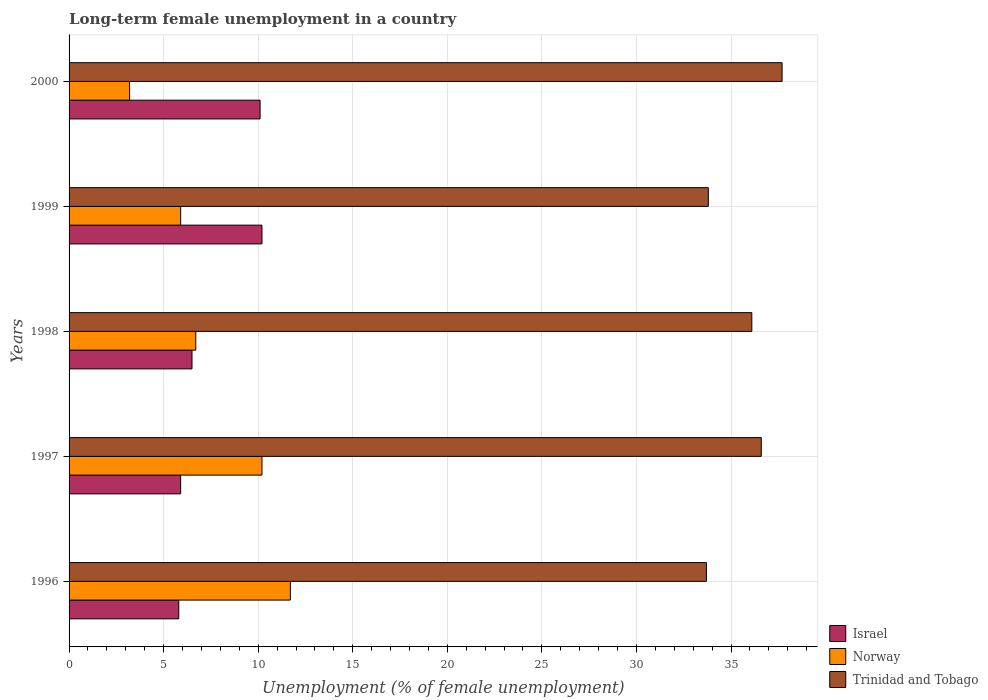How many different coloured bars are there?
Your answer should be very brief. 3. How many groups of bars are there?
Your answer should be very brief. 5. Are the number of bars per tick equal to the number of legend labels?
Provide a short and direct response. Yes. Are the number of bars on each tick of the Y-axis equal?
Ensure brevity in your answer.  Yes. How many bars are there on the 4th tick from the top?
Offer a very short reply. 3. How many bars are there on the 2nd tick from the bottom?
Ensure brevity in your answer.  3. What is the label of the 3rd group of bars from the top?
Your answer should be compact. 1998. What is the percentage of long-term unemployed female population in Trinidad and Tobago in 1997?
Keep it short and to the point. 36.6. Across all years, what is the maximum percentage of long-term unemployed female population in Norway?
Make the answer very short. 11.7. Across all years, what is the minimum percentage of long-term unemployed female population in Trinidad and Tobago?
Keep it short and to the point. 33.7. What is the total percentage of long-term unemployed female population in Norway in the graph?
Provide a succinct answer. 37.7. What is the difference between the percentage of long-term unemployed female population in Israel in 1996 and that in 1998?
Provide a short and direct response. -0.7. What is the difference between the percentage of long-term unemployed female population in Norway in 2000 and the percentage of long-term unemployed female population in Israel in 1998?
Offer a very short reply. -3.3. What is the average percentage of long-term unemployed female population in Norway per year?
Provide a succinct answer. 7.54. In the year 1998, what is the difference between the percentage of long-term unemployed female population in Trinidad and Tobago and percentage of long-term unemployed female population in Israel?
Ensure brevity in your answer.  29.6. In how many years, is the percentage of long-term unemployed female population in Trinidad and Tobago greater than 19 %?
Give a very brief answer. 5. What is the ratio of the percentage of long-term unemployed female population in Norway in 1996 to that in 2000?
Your response must be concise. 3.66. Is the difference between the percentage of long-term unemployed female population in Trinidad and Tobago in 1996 and 2000 greater than the difference between the percentage of long-term unemployed female population in Israel in 1996 and 2000?
Offer a very short reply. Yes. What is the difference between the highest and the second highest percentage of long-term unemployed female population in Trinidad and Tobago?
Your answer should be compact. 1.1. What is the difference between the highest and the lowest percentage of long-term unemployed female population in Israel?
Offer a very short reply. 4.4. In how many years, is the percentage of long-term unemployed female population in Norway greater than the average percentage of long-term unemployed female population in Norway taken over all years?
Make the answer very short. 2. Is it the case that in every year, the sum of the percentage of long-term unemployed female population in Trinidad and Tobago and percentage of long-term unemployed female population in Norway is greater than the percentage of long-term unemployed female population in Israel?
Keep it short and to the point. Yes. How many bars are there?
Your response must be concise. 15. Are all the bars in the graph horizontal?
Offer a terse response. Yes. How many years are there in the graph?
Your answer should be compact. 5. What is the difference between two consecutive major ticks on the X-axis?
Your response must be concise. 5. Are the values on the major ticks of X-axis written in scientific E-notation?
Your answer should be very brief. No. Does the graph contain any zero values?
Ensure brevity in your answer.  No. Does the graph contain grids?
Offer a very short reply. Yes. Where does the legend appear in the graph?
Offer a terse response. Bottom right. How are the legend labels stacked?
Keep it short and to the point. Vertical. What is the title of the graph?
Your response must be concise. Long-term female unemployment in a country. Does "Benin" appear as one of the legend labels in the graph?
Ensure brevity in your answer.  No. What is the label or title of the X-axis?
Ensure brevity in your answer.  Unemployment (% of female unemployment). What is the label or title of the Y-axis?
Ensure brevity in your answer.  Years. What is the Unemployment (% of female unemployment) in Israel in 1996?
Give a very brief answer. 5.8. What is the Unemployment (% of female unemployment) of Norway in 1996?
Make the answer very short. 11.7. What is the Unemployment (% of female unemployment) in Trinidad and Tobago in 1996?
Offer a terse response. 33.7. What is the Unemployment (% of female unemployment) in Israel in 1997?
Your response must be concise. 5.9. What is the Unemployment (% of female unemployment) in Norway in 1997?
Keep it short and to the point. 10.2. What is the Unemployment (% of female unemployment) in Trinidad and Tobago in 1997?
Keep it short and to the point. 36.6. What is the Unemployment (% of female unemployment) of Israel in 1998?
Offer a very short reply. 6.5. What is the Unemployment (% of female unemployment) in Norway in 1998?
Provide a succinct answer. 6.7. What is the Unemployment (% of female unemployment) of Trinidad and Tobago in 1998?
Make the answer very short. 36.1. What is the Unemployment (% of female unemployment) in Israel in 1999?
Provide a short and direct response. 10.2. What is the Unemployment (% of female unemployment) in Norway in 1999?
Offer a very short reply. 5.9. What is the Unemployment (% of female unemployment) in Trinidad and Tobago in 1999?
Ensure brevity in your answer.  33.8. What is the Unemployment (% of female unemployment) in Israel in 2000?
Offer a terse response. 10.1. What is the Unemployment (% of female unemployment) in Norway in 2000?
Provide a succinct answer. 3.2. What is the Unemployment (% of female unemployment) in Trinidad and Tobago in 2000?
Offer a terse response. 37.7. Across all years, what is the maximum Unemployment (% of female unemployment) in Israel?
Make the answer very short. 10.2. Across all years, what is the maximum Unemployment (% of female unemployment) of Norway?
Your response must be concise. 11.7. Across all years, what is the maximum Unemployment (% of female unemployment) in Trinidad and Tobago?
Your answer should be compact. 37.7. Across all years, what is the minimum Unemployment (% of female unemployment) in Israel?
Give a very brief answer. 5.8. Across all years, what is the minimum Unemployment (% of female unemployment) of Norway?
Give a very brief answer. 3.2. Across all years, what is the minimum Unemployment (% of female unemployment) of Trinidad and Tobago?
Provide a short and direct response. 33.7. What is the total Unemployment (% of female unemployment) of Israel in the graph?
Offer a very short reply. 38.5. What is the total Unemployment (% of female unemployment) in Norway in the graph?
Your response must be concise. 37.7. What is the total Unemployment (% of female unemployment) in Trinidad and Tobago in the graph?
Your answer should be compact. 177.9. What is the difference between the Unemployment (% of female unemployment) of Israel in 1996 and that in 1998?
Ensure brevity in your answer.  -0.7. What is the difference between the Unemployment (% of female unemployment) in Norway in 1996 and that in 1998?
Keep it short and to the point. 5. What is the difference between the Unemployment (% of female unemployment) of Norway in 1996 and that in 1999?
Offer a very short reply. 5.8. What is the difference between the Unemployment (% of female unemployment) of Trinidad and Tobago in 1996 and that in 1999?
Offer a very short reply. -0.1. What is the difference between the Unemployment (% of female unemployment) of Israel in 1996 and that in 2000?
Offer a terse response. -4.3. What is the difference between the Unemployment (% of female unemployment) of Norway in 1996 and that in 2000?
Your response must be concise. 8.5. What is the difference between the Unemployment (% of female unemployment) of Trinidad and Tobago in 1997 and that in 1998?
Your answer should be compact. 0.5. What is the difference between the Unemployment (% of female unemployment) of Israel in 1997 and that in 1999?
Provide a short and direct response. -4.3. What is the difference between the Unemployment (% of female unemployment) of Norway in 1997 and that in 1999?
Offer a terse response. 4.3. What is the difference between the Unemployment (% of female unemployment) in Trinidad and Tobago in 1997 and that in 1999?
Your response must be concise. 2.8. What is the difference between the Unemployment (% of female unemployment) of Trinidad and Tobago in 1997 and that in 2000?
Provide a short and direct response. -1.1. What is the difference between the Unemployment (% of female unemployment) in Norway in 1998 and that in 1999?
Keep it short and to the point. 0.8. What is the difference between the Unemployment (% of female unemployment) in Israel in 1998 and that in 2000?
Your answer should be very brief. -3.6. What is the difference between the Unemployment (% of female unemployment) in Norway in 1998 and that in 2000?
Your answer should be compact. 3.5. What is the difference between the Unemployment (% of female unemployment) in Trinidad and Tobago in 1998 and that in 2000?
Ensure brevity in your answer.  -1.6. What is the difference between the Unemployment (% of female unemployment) in Norway in 1999 and that in 2000?
Ensure brevity in your answer.  2.7. What is the difference between the Unemployment (% of female unemployment) of Israel in 1996 and the Unemployment (% of female unemployment) of Trinidad and Tobago in 1997?
Offer a terse response. -30.8. What is the difference between the Unemployment (% of female unemployment) of Norway in 1996 and the Unemployment (% of female unemployment) of Trinidad and Tobago in 1997?
Offer a very short reply. -24.9. What is the difference between the Unemployment (% of female unemployment) in Israel in 1996 and the Unemployment (% of female unemployment) in Norway in 1998?
Keep it short and to the point. -0.9. What is the difference between the Unemployment (% of female unemployment) of Israel in 1996 and the Unemployment (% of female unemployment) of Trinidad and Tobago in 1998?
Give a very brief answer. -30.3. What is the difference between the Unemployment (% of female unemployment) in Norway in 1996 and the Unemployment (% of female unemployment) in Trinidad and Tobago in 1998?
Provide a short and direct response. -24.4. What is the difference between the Unemployment (% of female unemployment) of Norway in 1996 and the Unemployment (% of female unemployment) of Trinidad and Tobago in 1999?
Make the answer very short. -22.1. What is the difference between the Unemployment (% of female unemployment) of Israel in 1996 and the Unemployment (% of female unemployment) of Norway in 2000?
Make the answer very short. 2.6. What is the difference between the Unemployment (% of female unemployment) of Israel in 1996 and the Unemployment (% of female unemployment) of Trinidad and Tobago in 2000?
Your answer should be compact. -31.9. What is the difference between the Unemployment (% of female unemployment) of Israel in 1997 and the Unemployment (% of female unemployment) of Trinidad and Tobago in 1998?
Keep it short and to the point. -30.2. What is the difference between the Unemployment (% of female unemployment) of Norway in 1997 and the Unemployment (% of female unemployment) of Trinidad and Tobago in 1998?
Make the answer very short. -25.9. What is the difference between the Unemployment (% of female unemployment) of Israel in 1997 and the Unemployment (% of female unemployment) of Norway in 1999?
Your answer should be compact. 0. What is the difference between the Unemployment (% of female unemployment) in Israel in 1997 and the Unemployment (% of female unemployment) in Trinidad and Tobago in 1999?
Offer a terse response. -27.9. What is the difference between the Unemployment (% of female unemployment) of Norway in 1997 and the Unemployment (% of female unemployment) of Trinidad and Tobago in 1999?
Your answer should be compact. -23.6. What is the difference between the Unemployment (% of female unemployment) in Israel in 1997 and the Unemployment (% of female unemployment) in Norway in 2000?
Make the answer very short. 2.7. What is the difference between the Unemployment (% of female unemployment) in Israel in 1997 and the Unemployment (% of female unemployment) in Trinidad and Tobago in 2000?
Provide a succinct answer. -31.8. What is the difference between the Unemployment (% of female unemployment) in Norway in 1997 and the Unemployment (% of female unemployment) in Trinidad and Tobago in 2000?
Provide a short and direct response. -27.5. What is the difference between the Unemployment (% of female unemployment) in Israel in 1998 and the Unemployment (% of female unemployment) in Norway in 1999?
Provide a succinct answer. 0.6. What is the difference between the Unemployment (% of female unemployment) in Israel in 1998 and the Unemployment (% of female unemployment) in Trinidad and Tobago in 1999?
Your response must be concise. -27.3. What is the difference between the Unemployment (% of female unemployment) in Norway in 1998 and the Unemployment (% of female unemployment) in Trinidad and Tobago in 1999?
Ensure brevity in your answer.  -27.1. What is the difference between the Unemployment (% of female unemployment) in Israel in 1998 and the Unemployment (% of female unemployment) in Norway in 2000?
Your answer should be very brief. 3.3. What is the difference between the Unemployment (% of female unemployment) in Israel in 1998 and the Unemployment (% of female unemployment) in Trinidad and Tobago in 2000?
Give a very brief answer. -31.2. What is the difference between the Unemployment (% of female unemployment) of Norway in 1998 and the Unemployment (% of female unemployment) of Trinidad and Tobago in 2000?
Ensure brevity in your answer.  -31. What is the difference between the Unemployment (% of female unemployment) of Israel in 1999 and the Unemployment (% of female unemployment) of Trinidad and Tobago in 2000?
Offer a very short reply. -27.5. What is the difference between the Unemployment (% of female unemployment) in Norway in 1999 and the Unemployment (% of female unemployment) in Trinidad and Tobago in 2000?
Provide a short and direct response. -31.8. What is the average Unemployment (% of female unemployment) in Israel per year?
Give a very brief answer. 7.7. What is the average Unemployment (% of female unemployment) of Norway per year?
Your response must be concise. 7.54. What is the average Unemployment (% of female unemployment) of Trinidad and Tobago per year?
Keep it short and to the point. 35.58. In the year 1996, what is the difference between the Unemployment (% of female unemployment) in Israel and Unemployment (% of female unemployment) in Trinidad and Tobago?
Provide a short and direct response. -27.9. In the year 1997, what is the difference between the Unemployment (% of female unemployment) of Israel and Unemployment (% of female unemployment) of Trinidad and Tobago?
Provide a short and direct response. -30.7. In the year 1997, what is the difference between the Unemployment (% of female unemployment) of Norway and Unemployment (% of female unemployment) of Trinidad and Tobago?
Provide a short and direct response. -26.4. In the year 1998, what is the difference between the Unemployment (% of female unemployment) in Israel and Unemployment (% of female unemployment) in Trinidad and Tobago?
Your answer should be compact. -29.6. In the year 1998, what is the difference between the Unemployment (% of female unemployment) in Norway and Unemployment (% of female unemployment) in Trinidad and Tobago?
Provide a succinct answer. -29.4. In the year 1999, what is the difference between the Unemployment (% of female unemployment) of Israel and Unemployment (% of female unemployment) of Trinidad and Tobago?
Give a very brief answer. -23.6. In the year 1999, what is the difference between the Unemployment (% of female unemployment) of Norway and Unemployment (% of female unemployment) of Trinidad and Tobago?
Your answer should be compact. -27.9. In the year 2000, what is the difference between the Unemployment (% of female unemployment) in Israel and Unemployment (% of female unemployment) in Trinidad and Tobago?
Provide a succinct answer. -27.6. In the year 2000, what is the difference between the Unemployment (% of female unemployment) of Norway and Unemployment (% of female unemployment) of Trinidad and Tobago?
Your response must be concise. -34.5. What is the ratio of the Unemployment (% of female unemployment) of Israel in 1996 to that in 1997?
Offer a terse response. 0.98. What is the ratio of the Unemployment (% of female unemployment) in Norway in 1996 to that in 1997?
Your answer should be very brief. 1.15. What is the ratio of the Unemployment (% of female unemployment) in Trinidad and Tobago in 1996 to that in 1997?
Offer a terse response. 0.92. What is the ratio of the Unemployment (% of female unemployment) in Israel in 1996 to that in 1998?
Your answer should be compact. 0.89. What is the ratio of the Unemployment (% of female unemployment) of Norway in 1996 to that in 1998?
Offer a terse response. 1.75. What is the ratio of the Unemployment (% of female unemployment) of Trinidad and Tobago in 1996 to that in 1998?
Your answer should be very brief. 0.93. What is the ratio of the Unemployment (% of female unemployment) in Israel in 1996 to that in 1999?
Make the answer very short. 0.57. What is the ratio of the Unemployment (% of female unemployment) in Norway in 1996 to that in 1999?
Give a very brief answer. 1.98. What is the ratio of the Unemployment (% of female unemployment) of Trinidad and Tobago in 1996 to that in 1999?
Your answer should be compact. 1. What is the ratio of the Unemployment (% of female unemployment) of Israel in 1996 to that in 2000?
Offer a very short reply. 0.57. What is the ratio of the Unemployment (% of female unemployment) in Norway in 1996 to that in 2000?
Ensure brevity in your answer.  3.66. What is the ratio of the Unemployment (% of female unemployment) in Trinidad and Tobago in 1996 to that in 2000?
Provide a succinct answer. 0.89. What is the ratio of the Unemployment (% of female unemployment) of Israel in 1997 to that in 1998?
Give a very brief answer. 0.91. What is the ratio of the Unemployment (% of female unemployment) of Norway in 1997 to that in 1998?
Make the answer very short. 1.52. What is the ratio of the Unemployment (% of female unemployment) of Trinidad and Tobago in 1997 to that in 1998?
Provide a succinct answer. 1.01. What is the ratio of the Unemployment (% of female unemployment) in Israel in 1997 to that in 1999?
Provide a short and direct response. 0.58. What is the ratio of the Unemployment (% of female unemployment) in Norway in 1997 to that in 1999?
Offer a very short reply. 1.73. What is the ratio of the Unemployment (% of female unemployment) in Trinidad and Tobago in 1997 to that in 1999?
Your response must be concise. 1.08. What is the ratio of the Unemployment (% of female unemployment) in Israel in 1997 to that in 2000?
Your response must be concise. 0.58. What is the ratio of the Unemployment (% of female unemployment) of Norway in 1997 to that in 2000?
Ensure brevity in your answer.  3.19. What is the ratio of the Unemployment (% of female unemployment) of Trinidad and Tobago in 1997 to that in 2000?
Keep it short and to the point. 0.97. What is the ratio of the Unemployment (% of female unemployment) in Israel in 1998 to that in 1999?
Give a very brief answer. 0.64. What is the ratio of the Unemployment (% of female unemployment) in Norway in 1998 to that in 1999?
Your answer should be very brief. 1.14. What is the ratio of the Unemployment (% of female unemployment) of Trinidad and Tobago in 1998 to that in 1999?
Your answer should be very brief. 1.07. What is the ratio of the Unemployment (% of female unemployment) of Israel in 1998 to that in 2000?
Offer a terse response. 0.64. What is the ratio of the Unemployment (% of female unemployment) in Norway in 1998 to that in 2000?
Make the answer very short. 2.09. What is the ratio of the Unemployment (% of female unemployment) of Trinidad and Tobago in 1998 to that in 2000?
Your answer should be compact. 0.96. What is the ratio of the Unemployment (% of female unemployment) in Israel in 1999 to that in 2000?
Offer a very short reply. 1.01. What is the ratio of the Unemployment (% of female unemployment) of Norway in 1999 to that in 2000?
Give a very brief answer. 1.84. What is the ratio of the Unemployment (% of female unemployment) of Trinidad and Tobago in 1999 to that in 2000?
Give a very brief answer. 0.9. What is the difference between the highest and the second highest Unemployment (% of female unemployment) of Norway?
Your answer should be compact. 1.5. What is the difference between the highest and the second highest Unemployment (% of female unemployment) in Trinidad and Tobago?
Your answer should be compact. 1.1. What is the difference between the highest and the lowest Unemployment (% of female unemployment) of Israel?
Your answer should be compact. 4.4. What is the difference between the highest and the lowest Unemployment (% of female unemployment) of Norway?
Your answer should be compact. 8.5. What is the difference between the highest and the lowest Unemployment (% of female unemployment) of Trinidad and Tobago?
Make the answer very short. 4. 